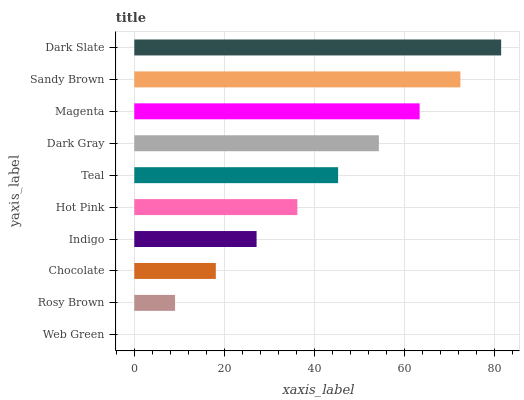Is Web Green the minimum?
Answer yes or no. Yes. Is Dark Slate the maximum?
Answer yes or no. Yes. Is Rosy Brown the minimum?
Answer yes or no. No. Is Rosy Brown the maximum?
Answer yes or no. No. Is Rosy Brown greater than Web Green?
Answer yes or no. Yes. Is Web Green less than Rosy Brown?
Answer yes or no. Yes. Is Web Green greater than Rosy Brown?
Answer yes or no. No. Is Rosy Brown less than Web Green?
Answer yes or no. No. Is Teal the high median?
Answer yes or no. Yes. Is Hot Pink the low median?
Answer yes or no. Yes. Is Dark Gray the high median?
Answer yes or no. No. Is Web Green the low median?
Answer yes or no. No. 